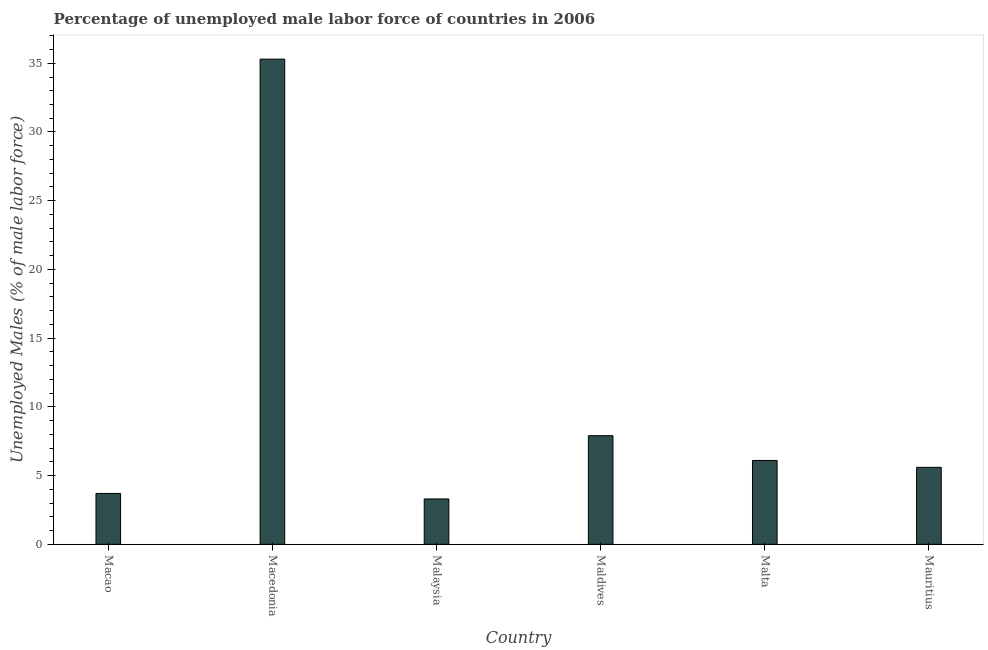Does the graph contain any zero values?
Provide a short and direct response. No. Does the graph contain grids?
Your response must be concise. No. What is the title of the graph?
Give a very brief answer. Percentage of unemployed male labor force of countries in 2006. What is the label or title of the Y-axis?
Provide a succinct answer. Unemployed Males (% of male labor force). What is the total unemployed male labour force in Malta?
Offer a very short reply. 6.1. Across all countries, what is the maximum total unemployed male labour force?
Offer a terse response. 35.3. Across all countries, what is the minimum total unemployed male labour force?
Give a very brief answer. 3.3. In which country was the total unemployed male labour force maximum?
Offer a very short reply. Macedonia. In which country was the total unemployed male labour force minimum?
Your answer should be compact. Malaysia. What is the sum of the total unemployed male labour force?
Your answer should be very brief. 61.9. What is the difference between the total unemployed male labour force in Macedonia and Mauritius?
Keep it short and to the point. 29.7. What is the average total unemployed male labour force per country?
Provide a succinct answer. 10.32. What is the median total unemployed male labour force?
Offer a terse response. 5.85. What is the ratio of the total unemployed male labour force in Macedonia to that in Malta?
Give a very brief answer. 5.79. Is the total unemployed male labour force in Malaysia less than that in Mauritius?
Make the answer very short. Yes. Is the difference between the total unemployed male labour force in Macedonia and Mauritius greater than the difference between any two countries?
Your answer should be compact. No. What is the difference between the highest and the second highest total unemployed male labour force?
Your answer should be very brief. 27.4. Is the sum of the total unemployed male labour force in Macedonia and Malaysia greater than the maximum total unemployed male labour force across all countries?
Your response must be concise. Yes. In how many countries, is the total unemployed male labour force greater than the average total unemployed male labour force taken over all countries?
Your answer should be compact. 1. How many bars are there?
Ensure brevity in your answer.  6. How many countries are there in the graph?
Keep it short and to the point. 6. What is the Unemployed Males (% of male labor force) in Macao?
Your response must be concise. 3.7. What is the Unemployed Males (% of male labor force) of Macedonia?
Your answer should be compact. 35.3. What is the Unemployed Males (% of male labor force) of Malaysia?
Offer a terse response. 3.3. What is the Unemployed Males (% of male labor force) in Maldives?
Provide a short and direct response. 7.9. What is the Unemployed Males (% of male labor force) of Malta?
Ensure brevity in your answer.  6.1. What is the Unemployed Males (% of male labor force) of Mauritius?
Make the answer very short. 5.6. What is the difference between the Unemployed Males (% of male labor force) in Macao and Macedonia?
Keep it short and to the point. -31.6. What is the difference between the Unemployed Males (% of male labor force) in Macao and Malaysia?
Provide a short and direct response. 0.4. What is the difference between the Unemployed Males (% of male labor force) in Macao and Malta?
Your answer should be very brief. -2.4. What is the difference between the Unemployed Males (% of male labor force) in Macedonia and Maldives?
Keep it short and to the point. 27.4. What is the difference between the Unemployed Males (% of male labor force) in Macedonia and Malta?
Ensure brevity in your answer.  29.2. What is the difference between the Unemployed Males (% of male labor force) in Macedonia and Mauritius?
Keep it short and to the point. 29.7. What is the difference between the Unemployed Males (% of male labor force) in Malaysia and Malta?
Your answer should be compact. -2.8. What is the difference between the Unemployed Males (% of male labor force) in Maldives and Mauritius?
Ensure brevity in your answer.  2.3. What is the difference between the Unemployed Males (% of male labor force) in Malta and Mauritius?
Offer a terse response. 0.5. What is the ratio of the Unemployed Males (% of male labor force) in Macao to that in Macedonia?
Keep it short and to the point. 0.1. What is the ratio of the Unemployed Males (% of male labor force) in Macao to that in Malaysia?
Your answer should be compact. 1.12. What is the ratio of the Unemployed Males (% of male labor force) in Macao to that in Maldives?
Offer a terse response. 0.47. What is the ratio of the Unemployed Males (% of male labor force) in Macao to that in Malta?
Ensure brevity in your answer.  0.61. What is the ratio of the Unemployed Males (% of male labor force) in Macao to that in Mauritius?
Offer a terse response. 0.66. What is the ratio of the Unemployed Males (% of male labor force) in Macedonia to that in Malaysia?
Give a very brief answer. 10.7. What is the ratio of the Unemployed Males (% of male labor force) in Macedonia to that in Maldives?
Ensure brevity in your answer.  4.47. What is the ratio of the Unemployed Males (% of male labor force) in Macedonia to that in Malta?
Your answer should be very brief. 5.79. What is the ratio of the Unemployed Males (% of male labor force) in Macedonia to that in Mauritius?
Offer a very short reply. 6.3. What is the ratio of the Unemployed Males (% of male labor force) in Malaysia to that in Maldives?
Keep it short and to the point. 0.42. What is the ratio of the Unemployed Males (% of male labor force) in Malaysia to that in Malta?
Your answer should be very brief. 0.54. What is the ratio of the Unemployed Males (% of male labor force) in Malaysia to that in Mauritius?
Provide a succinct answer. 0.59. What is the ratio of the Unemployed Males (% of male labor force) in Maldives to that in Malta?
Your response must be concise. 1.29. What is the ratio of the Unemployed Males (% of male labor force) in Maldives to that in Mauritius?
Provide a succinct answer. 1.41. What is the ratio of the Unemployed Males (% of male labor force) in Malta to that in Mauritius?
Keep it short and to the point. 1.09. 